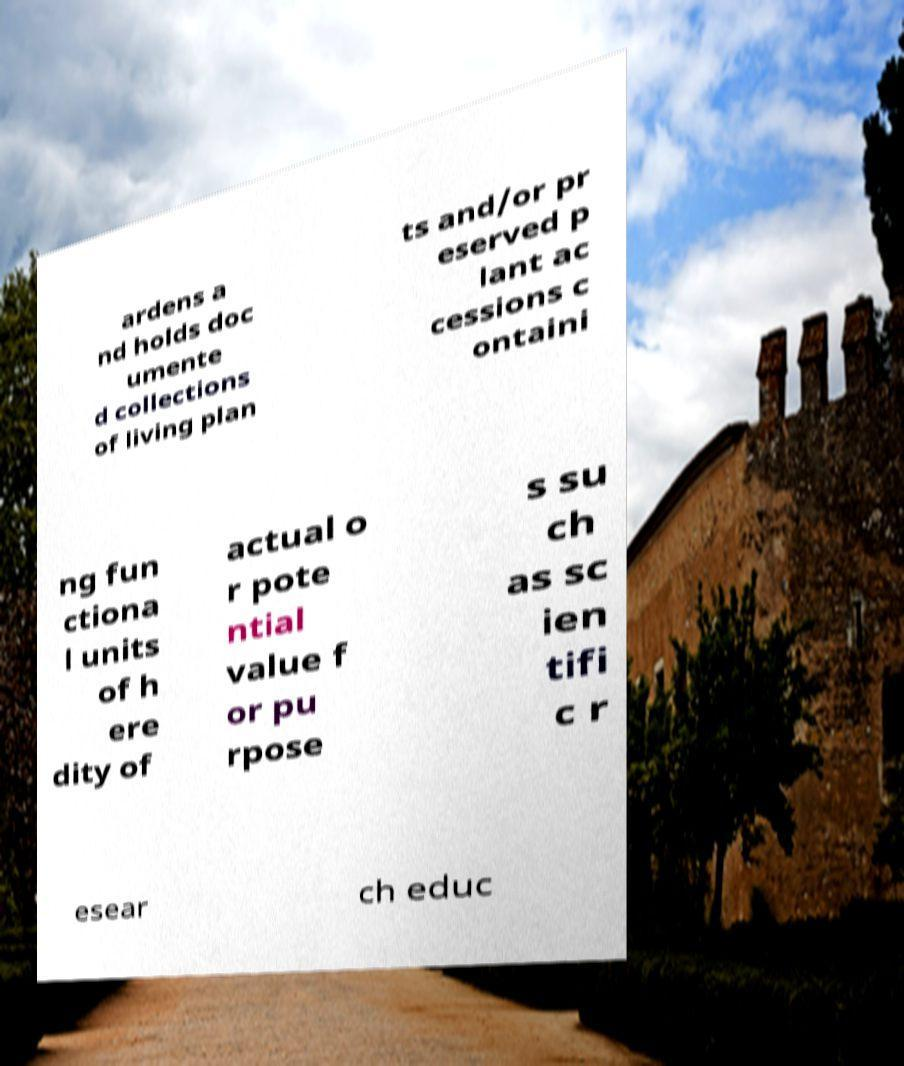Can you accurately transcribe the text from the provided image for me? ardens a nd holds doc umente d collections of living plan ts and/or pr eserved p lant ac cessions c ontaini ng fun ctiona l units of h ere dity of actual o r pote ntial value f or pu rpose s su ch as sc ien tifi c r esear ch educ 